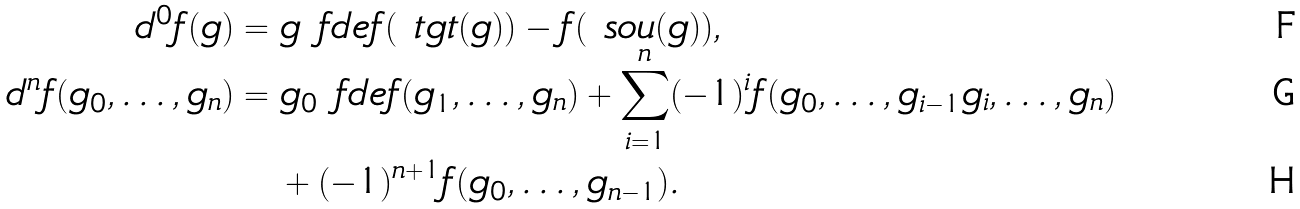<formula> <loc_0><loc_0><loc_500><loc_500>d ^ { 0 } f ( g ) & = g \ f d e f ( \ t g t ( g ) ) - f ( \ s o u ( g ) ) , \\ d ^ { n } f ( g _ { 0 } , \dots , g _ { n } ) & = g _ { 0 } \ f d e f ( g _ { 1 } , \dots , g _ { n } ) + \sum _ { i = 1 } ^ { n } ( - 1 ) ^ { i } f ( g _ { 0 } , \dots , g _ { i - 1 } g _ { i } , \dots , g _ { n } ) \\ & \quad + ( - 1 ) ^ { n + 1 } f ( g _ { 0 } , \dots , g _ { n - 1 } ) .</formula> 